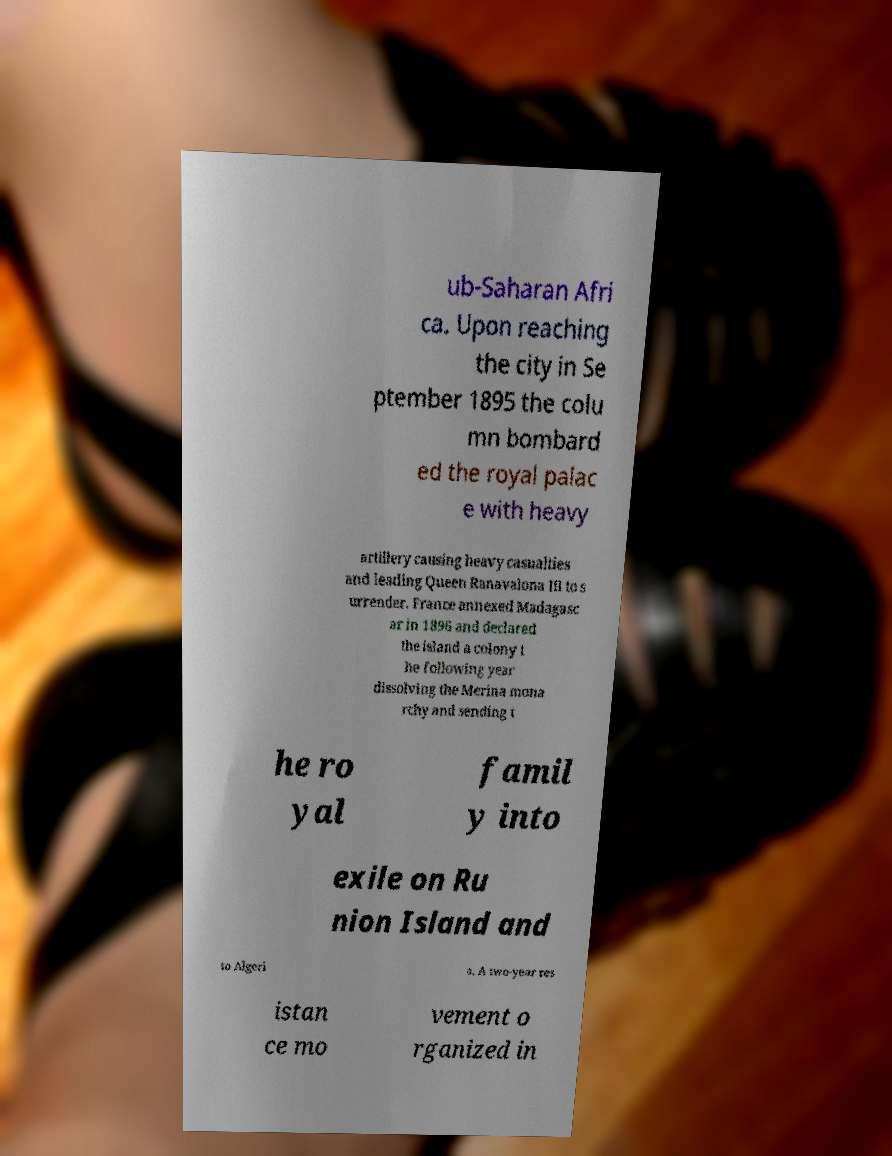I need the written content from this picture converted into text. Can you do that? ub-Saharan Afri ca. Upon reaching the city in Se ptember 1895 the colu mn bombard ed the royal palac e with heavy artillery causing heavy casualties and leading Queen Ranavalona III to s urrender. France annexed Madagasc ar in 1896 and declared the island a colony t he following year dissolving the Merina mona rchy and sending t he ro yal famil y into exile on Ru nion Island and to Algeri a. A two-year res istan ce mo vement o rganized in 